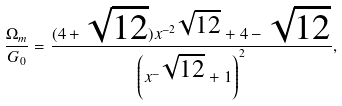Convert formula to latex. <formula><loc_0><loc_0><loc_500><loc_500>\frac { \Omega _ { m } } { G _ { 0 } } = \frac { ( 4 + \sqrt { 1 2 } ) x ^ { - 2 \sqrt { 1 2 } } + 4 - \sqrt { 1 2 } } { \left ( x ^ { - \sqrt { 1 2 } } + 1 \right ) ^ { 2 } } ,</formula> 